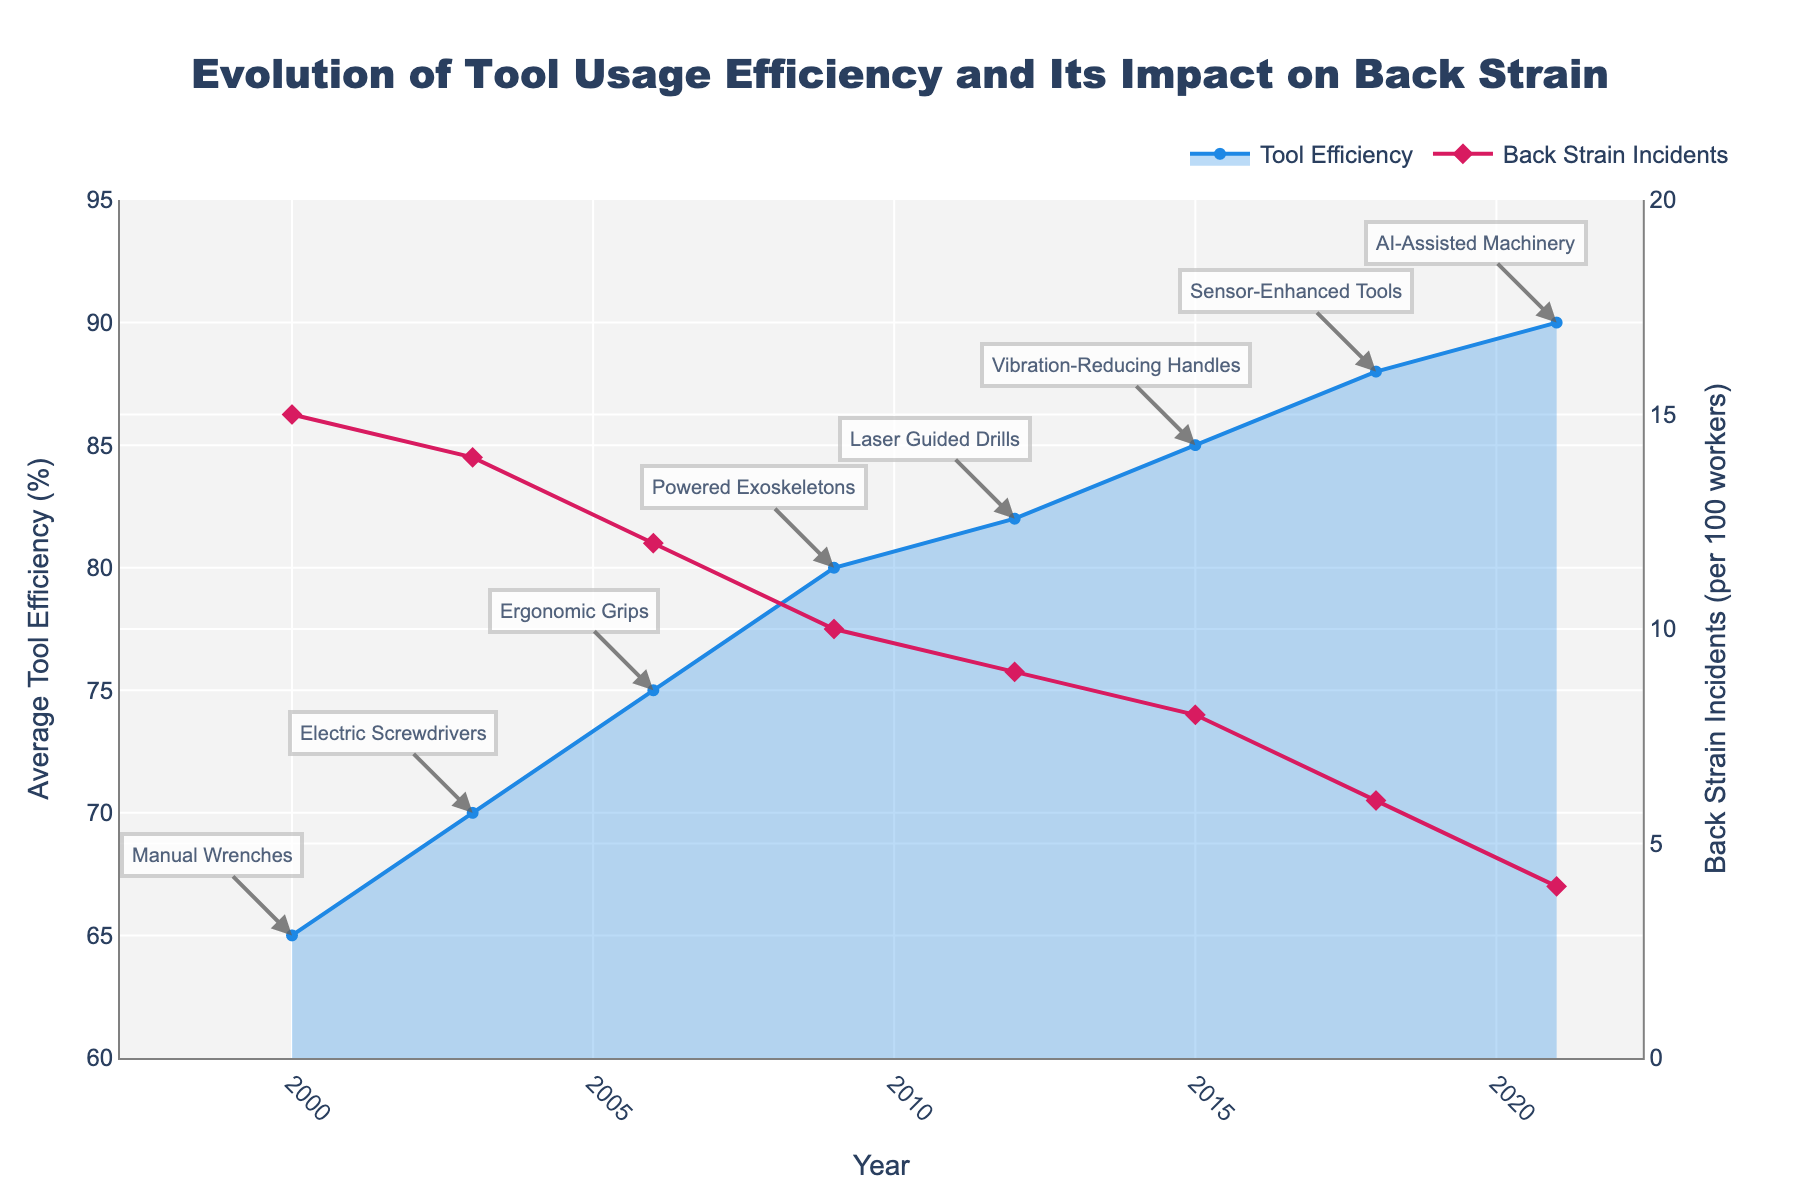When did the tool efficiency first reach 70%? The year when tool efficiency reached 70% can be found by looking at the 'Average Tool Efficiency (%)' line and identifying the point where it first touches or exceeds 70%. According to the plot, this occurs in 2003.
Answer: 2003 How many back strain incidents were reported in 2012? To find the number of back strain incidents in 2012, locate the 'Back Strain Incidents (per 100 workers)' line and see the value at 2012. From the plot, it is 9 incidents per 100 workers.
Answer: 9 What is the difference in tool efficiency between 2000 and 2021? To calculate the difference, find the tool efficiency values for 2000 and 2021 from the plot. The value in 2000 is 65%, and in 2021, it is 90%. The difference is 90% - 65% = 25%.
Answer: 25% By how much did back strain incidents decrease from 2000 to 2021? First, find the number of back strain incidents in 2000 and 2021 from the plot. In 2000, there were 15 incidents, and in 2021, there were 4 incidents. The decrease is 15 - 4 = 11 incidents.
Answer: 11 Which tool innovation was introduced when the efficiency reached 75%? To determine the tool innovation, find the year when tool efficiency reached 75% and check the annotation for that year. According to the plot, ergonomic grips were introduced in 2006 when efficiency reached 75%.
Answer: Ergonomic Grips How did back strain incidents change between 2009 and 2018? Observe the 'Back Strain Incidents (per 100 workers)' line between 2009 and 2018. In 2009, incidents are at 10 per 100 workers, and in 2018, it decreases to 6 per 100 workers. The change is a reduction of 4 incidents.
Answer: Decreased by 4 What is the average tool efficiency from 2000 to 2021? Add the tool efficiency values from all years and divide by the number of data points. (65 + 70 + 75 + 80 + 82 + 85 + 88 + 90) / 8 = 635 / 8 = 79.375%
Answer: 79.375% Which tool innovation had the highest tool efficiency? Check the annotations for the highest tool efficiency point on the 'Average Tool Efficiency (%)' line. In 2021, AI-Assisted Machinery was introduced, and the efficiency is 90%.
Answer: AI-Assisted Machinery Are there any periods where tool efficiency did not increase for more than one consecutive innovation? Look for periods where the 'Average Tool Efficiency (%)' line remains flat or decreases for two consecutive data points. In the plot, no such periods are observed; the efficiency consistently increases with each innovation.
Answer: No What was the impact of powered exoskeletons on back strain incidents? Find the year when powered exoskeletons were introduced (2009) and compare the back strain incidents before and after. In 2006, back strain incidents were 12, and after 2009, incidents reduced to 10.
Answer: Reduced by 2 